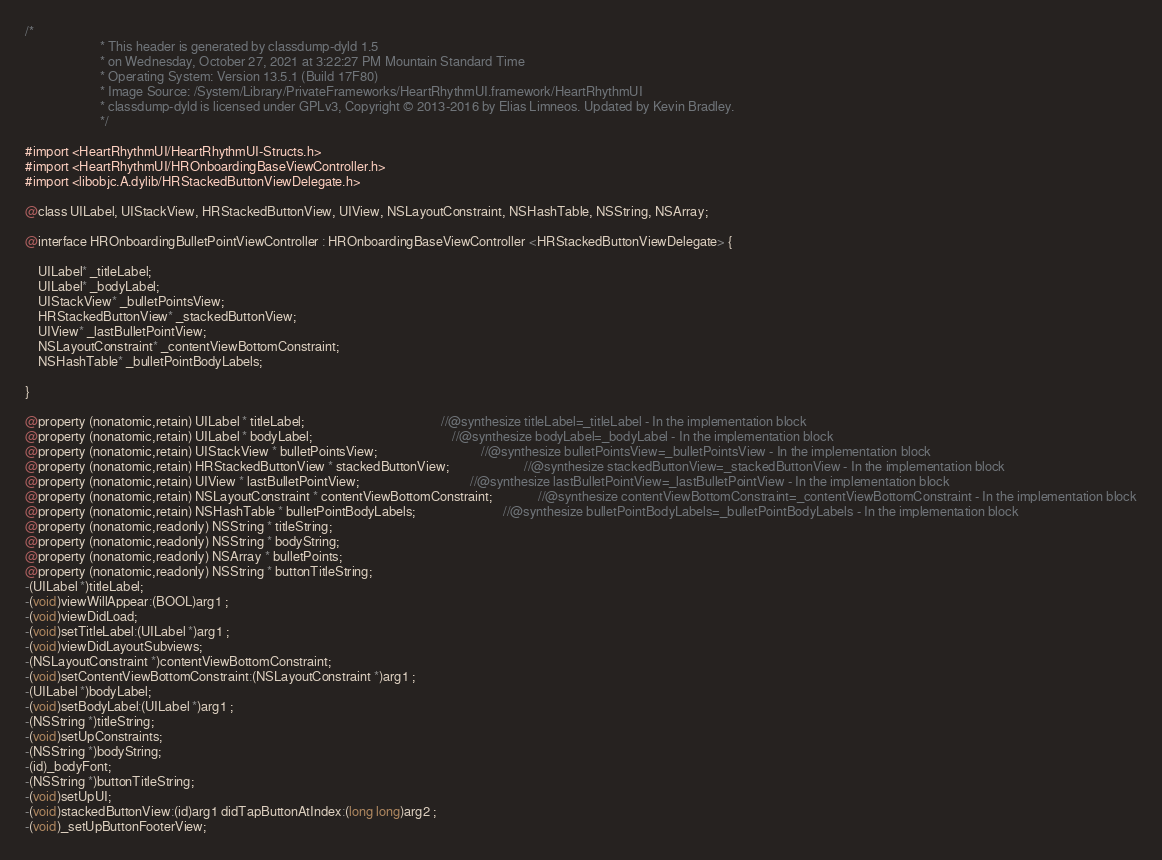Convert code to text. <code><loc_0><loc_0><loc_500><loc_500><_C_>/*
                       * This header is generated by classdump-dyld 1.5
                       * on Wednesday, October 27, 2021 at 3:22:27 PM Mountain Standard Time
                       * Operating System: Version 13.5.1 (Build 17F80)
                       * Image Source: /System/Library/PrivateFrameworks/HeartRhythmUI.framework/HeartRhythmUI
                       * classdump-dyld is licensed under GPLv3, Copyright © 2013-2016 by Elias Limneos. Updated by Kevin Bradley.
                       */

#import <HeartRhythmUI/HeartRhythmUI-Structs.h>
#import <HeartRhythmUI/HROnboardingBaseViewController.h>
#import <libobjc.A.dylib/HRStackedButtonViewDelegate.h>

@class UILabel, UIStackView, HRStackedButtonView, UIView, NSLayoutConstraint, NSHashTable, NSString, NSArray;

@interface HROnboardingBulletPointViewController : HROnboardingBaseViewController <HRStackedButtonViewDelegate> {

	UILabel* _titleLabel;
	UILabel* _bodyLabel;
	UIStackView* _bulletPointsView;
	HRStackedButtonView* _stackedButtonView;
	UIView* _lastBulletPointView;
	NSLayoutConstraint* _contentViewBottomConstraint;
	NSHashTable* _bulletPointBodyLabels;

}

@property (nonatomic,retain) UILabel * titleLabel;                                          //@synthesize titleLabel=_titleLabel - In the implementation block
@property (nonatomic,retain) UILabel * bodyLabel;                                           //@synthesize bodyLabel=_bodyLabel - In the implementation block
@property (nonatomic,retain) UIStackView * bulletPointsView;                                //@synthesize bulletPointsView=_bulletPointsView - In the implementation block
@property (nonatomic,retain) HRStackedButtonView * stackedButtonView;                       //@synthesize stackedButtonView=_stackedButtonView - In the implementation block
@property (nonatomic,retain) UIView * lastBulletPointView;                                  //@synthesize lastBulletPointView=_lastBulletPointView - In the implementation block
@property (nonatomic,retain) NSLayoutConstraint * contentViewBottomConstraint;              //@synthesize contentViewBottomConstraint=_contentViewBottomConstraint - In the implementation block
@property (nonatomic,retain) NSHashTable * bulletPointBodyLabels;                           //@synthesize bulletPointBodyLabels=_bulletPointBodyLabels - In the implementation block
@property (nonatomic,readonly) NSString * titleString; 
@property (nonatomic,readonly) NSString * bodyString; 
@property (nonatomic,readonly) NSArray * bulletPoints; 
@property (nonatomic,readonly) NSString * buttonTitleString; 
-(UILabel *)titleLabel;
-(void)viewWillAppear:(BOOL)arg1 ;
-(void)viewDidLoad;
-(void)setTitleLabel:(UILabel *)arg1 ;
-(void)viewDidLayoutSubviews;
-(NSLayoutConstraint *)contentViewBottomConstraint;
-(void)setContentViewBottomConstraint:(NSLayoutConstraint *)arg1 ;
-(UILabel *)bodyLabel;
-(void)setBodyLabel:(UILabel *)arg1 ;
-(NSString *)titleString;
-(void)setUpConstraints;
-(NSString *)bodyString;
-(id)_bodyFont;
-(NSString *)buttonTitleString;
-(void)setUpUI;
-(void)stackedButtonView:(id)arg1 didTapButtonAtIndex:(long long)arg2 ;
-(void)_setUpButtonFooterView;</code> 